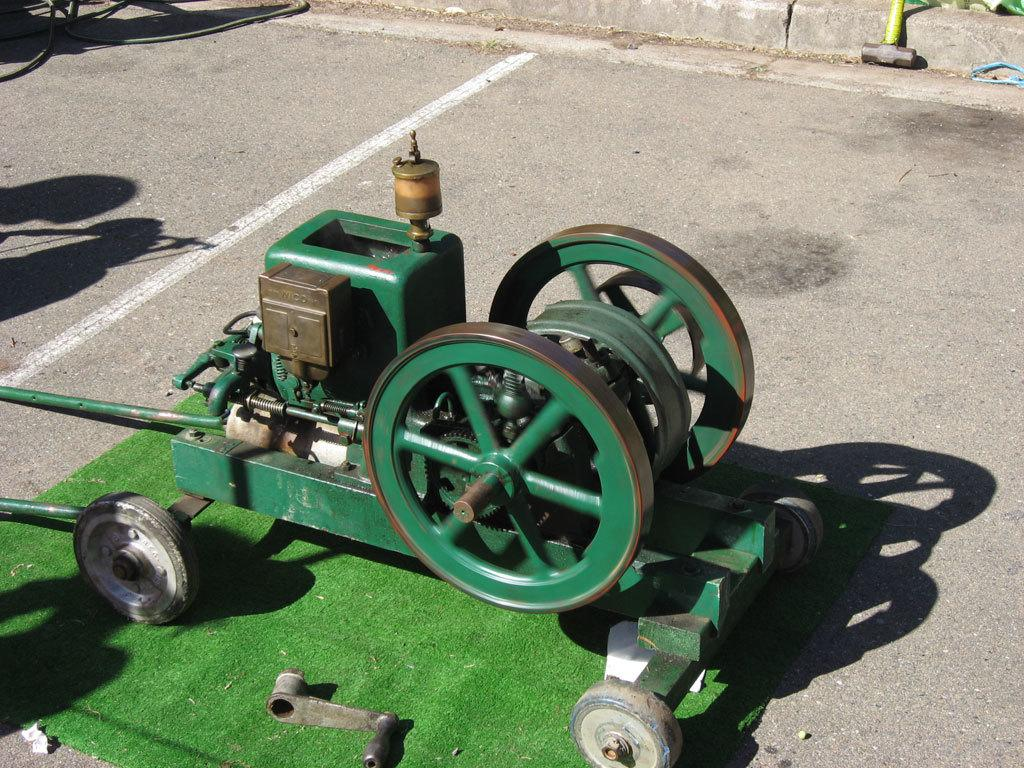What type of machine is in the image? There is a machine with wheels in the image. What is the machine placed on? The machine is placed on a green mat. What can be seen in the background of the image? There is a road with a white line in the image. Where is the tool located in the image? The tool is visible at the top of the image. What type of light is shining on the machine in the image? There is no light shining on the machine in the image. Can you see a fork in the image? There is no fork present in the image. 